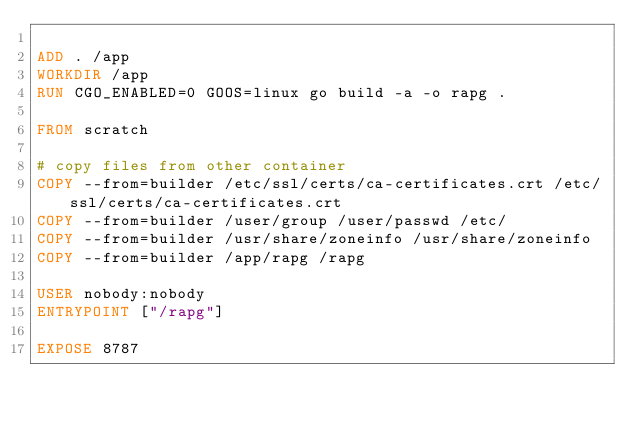<code> <loc_0><loc_0><loc_500><loc_500><_Dockerfile_>
ADD . /app
WORKDIR /app
RUN CGO_ENABLED=0 GOOS=linux go build -a -o rapg .

FROM scratch

# copy files from other container
COPY --from=builder /etc/ssl/certs/ca-certificates.crt /etc/ssl/certs/ca-certificates.crt
COPY --from=builder /user/group /user/passwd /etc/
COPY --from=builder /usr/share/zoneinfo /usr/share/zoneinfo
COPY --from=builder /app/rapg /rapg

USER nobody:nobody
ENTRYPOINT ["/rapg"]

EXPOSE 8787</code> 